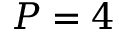Convert formula to latex. <formula><loc_0><loc_0><loc_500><loc_500>P = 4</formula> 